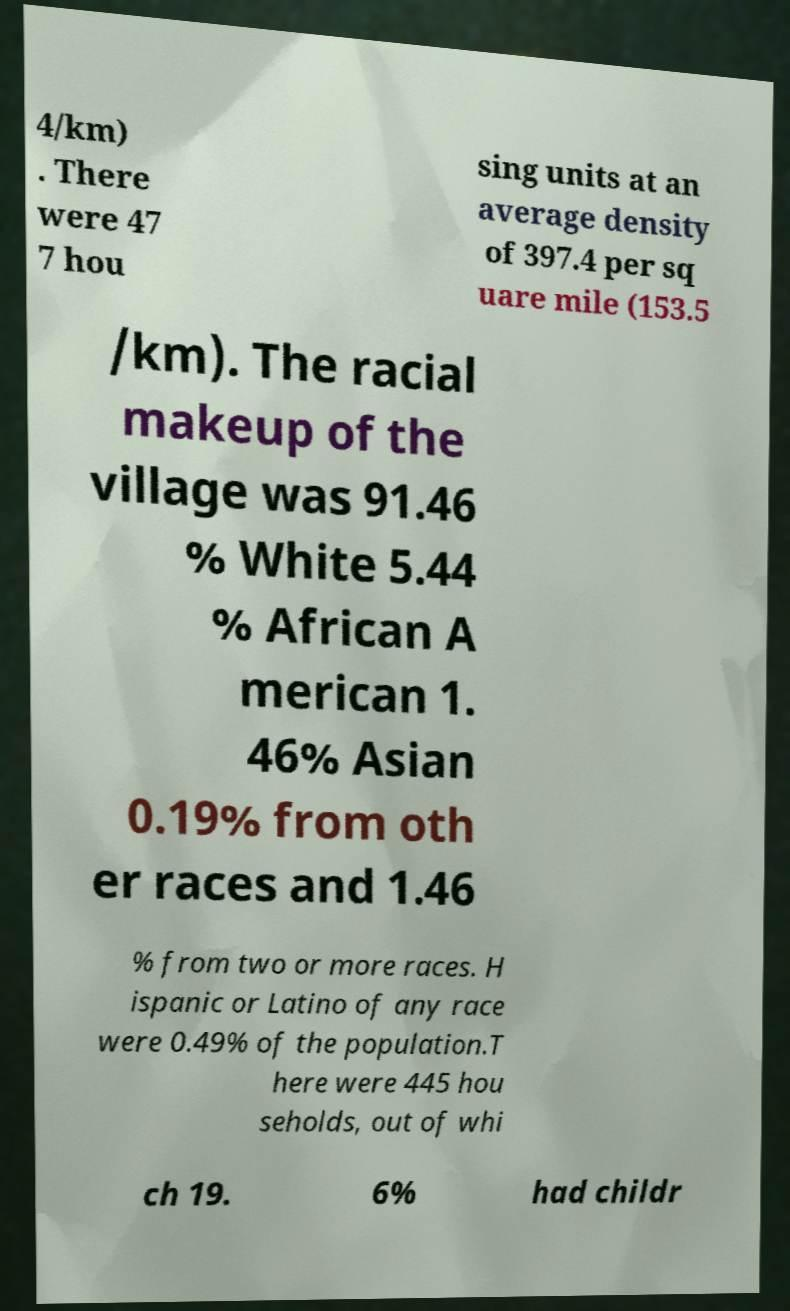Please identify and transcribe the text found in this image. 4/km) . There were 47 7 hou sing units at an average density of 397.4 per sq uare mile (153.5 /km). The racial makeup of the village was 91.46 % White 5.44 % African A merican 1. 46% Asian 0.19% from oth er races and 1.46 % from two or more races. H ispanic or Latino of any race were 0.49% of the population.T here were 445 hou seholds, out of whi ch 19. 6% had childr 